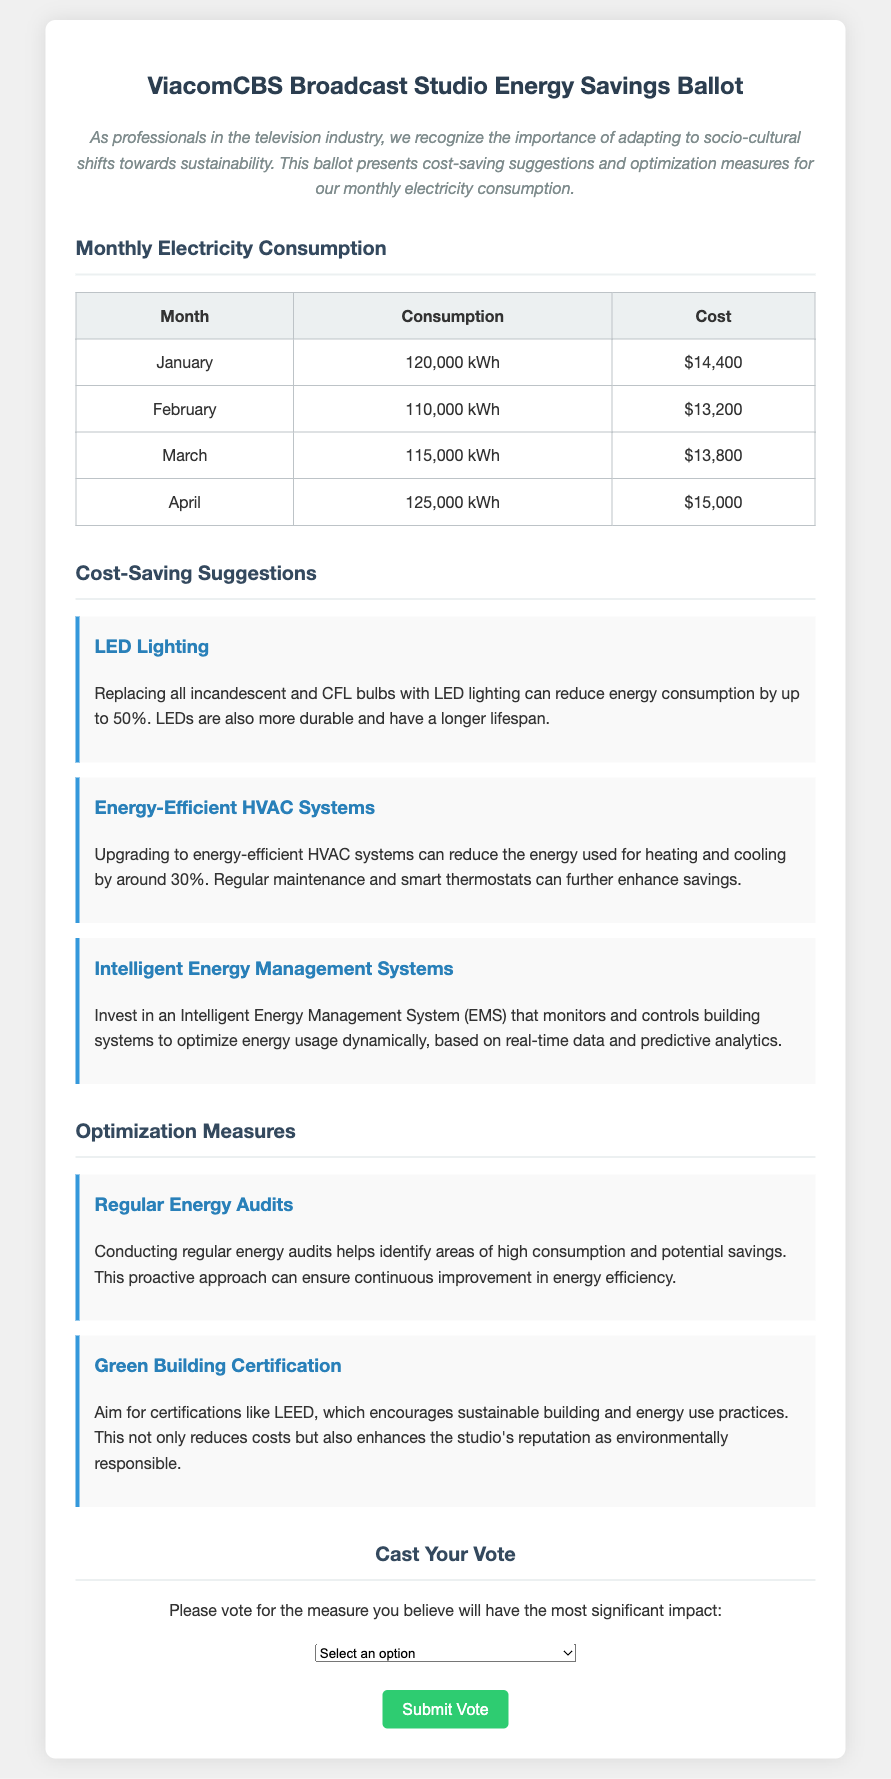What is the total electricity consumption in January? The January electricity consumption is listed as 120,000 kWh in the document.
Answer: 120,000 kWh What was the cost for February's electricity consumption? The document states that the cost for February's electricity consumption is $13,200.
Answer: $13,200 How much can LED lighting reduce energy consumption? The document mentions that LED lighting can reduce energy consumption by up to 50%.
Answer: 50% What is one of the suggestions for improving energy efficiency? The document provides several suggestions, one being the replacement of incandescent and CFL bulbs with LED lighting.
Answer: LED Lighting What does the acronym LEED stand for? In the context of the document, LEED refers to a certification encouraging sustainable building and energy use.
Answer: LEED How much energy can energy-efficient HVAC systems reduce? According to the document, energy-efficient HVAC systems can reduce energy use for heating and cooling by around 30%.
Answer: 30% Which month had the highest electricity consumption? The highest electricity consumption in the table is recorded in April at 125,000 kWh.
Answer: April What type of system is suggested for monitoring energy usage dynamically? The document suggests investing in an Intelligent Energy Management System (EMS) for optimizing energy usage.
Answer: Intelligent Energy Management System How should votes be submitted? The document states that votes can be submitted by selecting an option from the dropdown menu and clicking the submit button.
Answer: Dropdown menu and submit button 